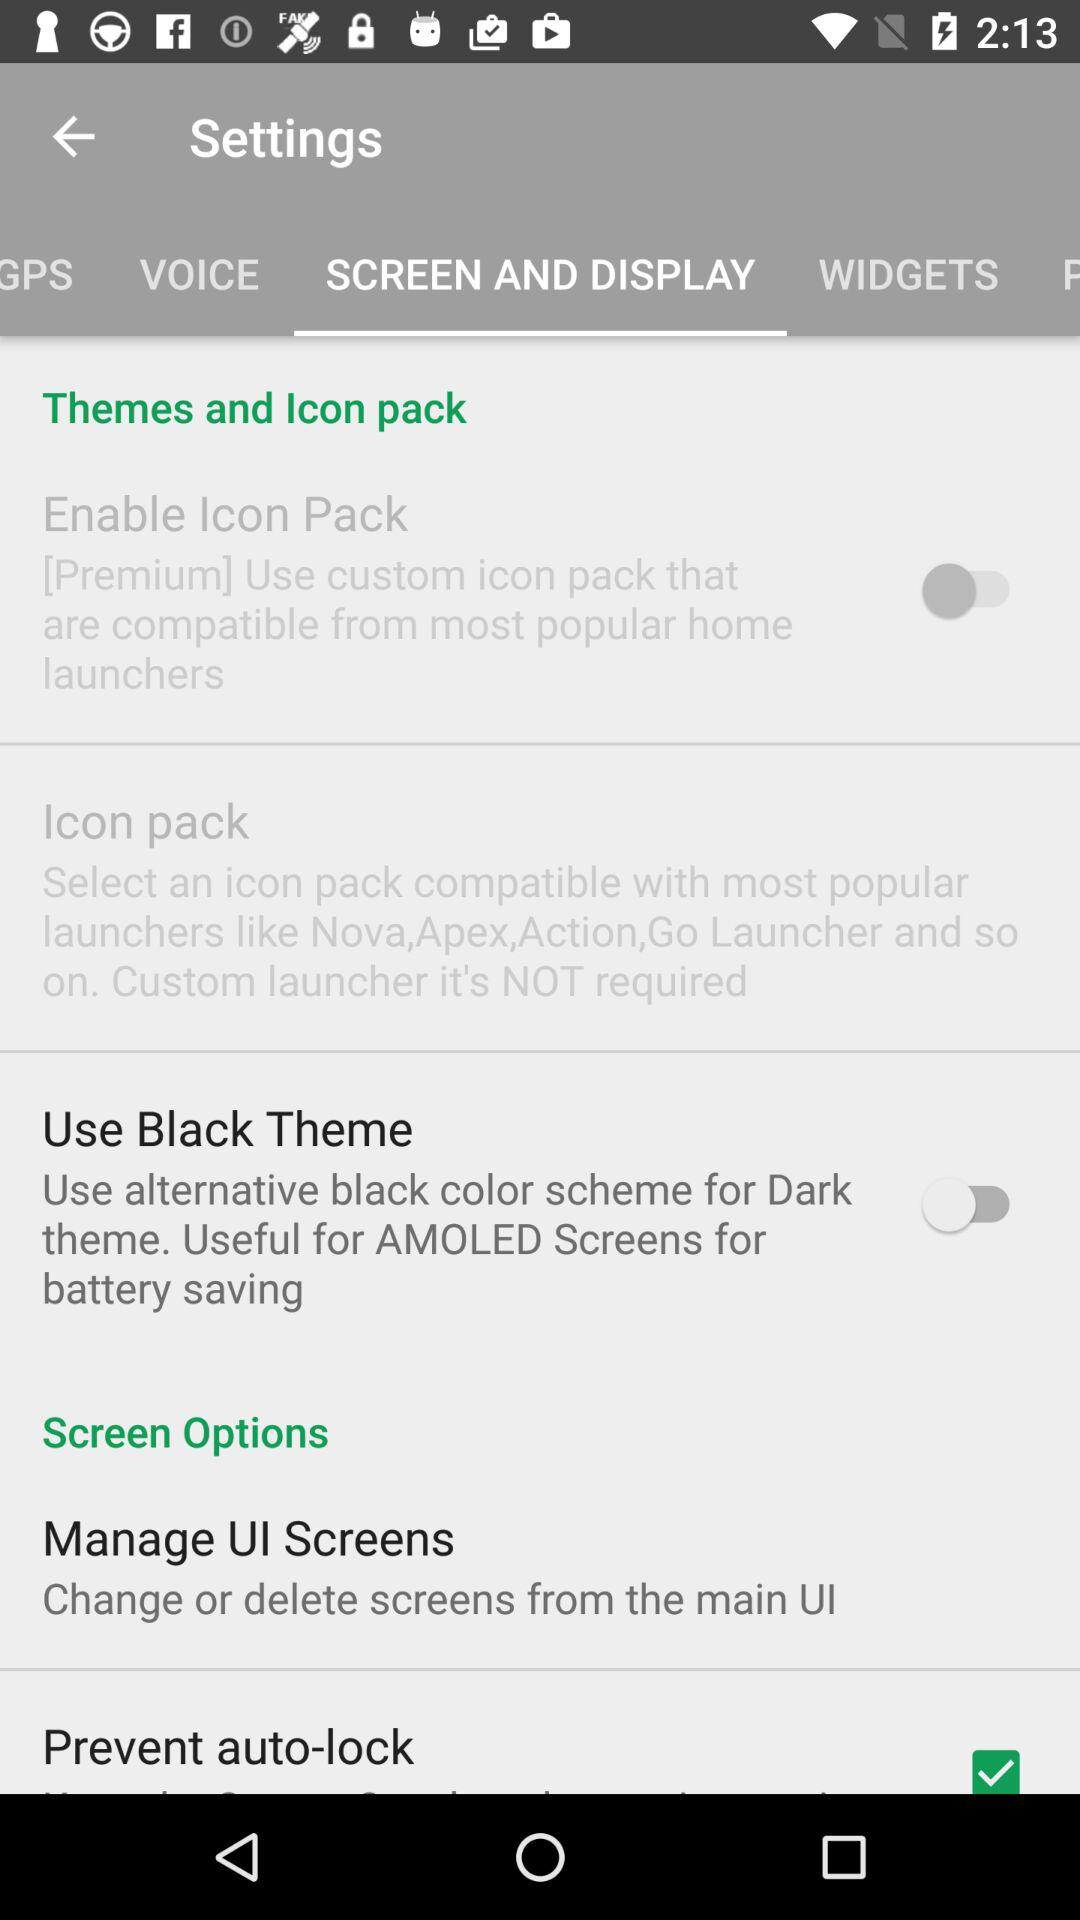What is the current status of "Prevent auto-lock"? The current status of "Prevent auto-lock" is "on". 